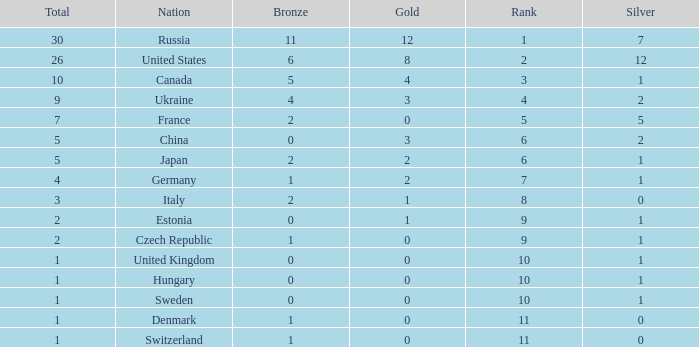How many silvers have a Nation of hungary, and a Rank larger than 10? 0.0. 